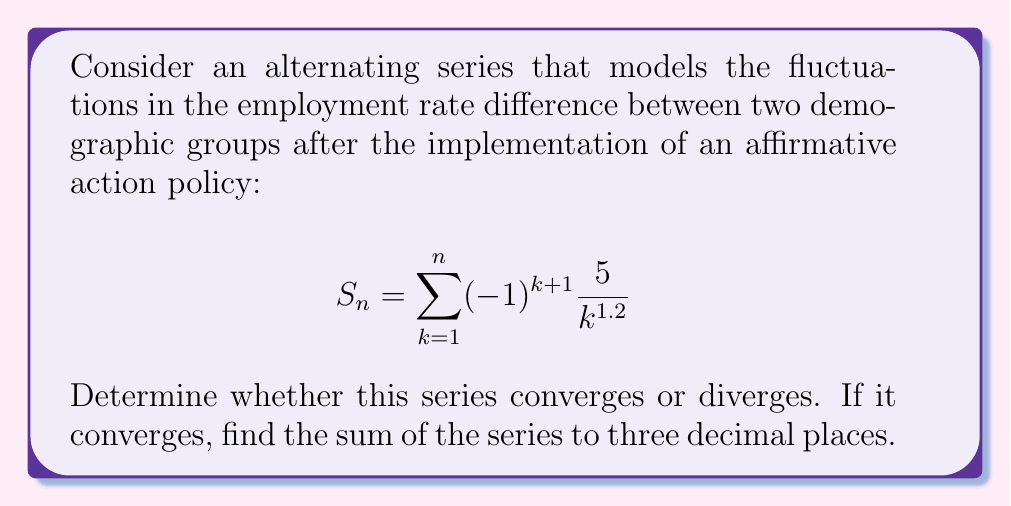Can you solve this math problem? To determine the convergence and sum of this alternating series, we'll use the Alternating Series Test and the Alternating Series Estimation Theorem.

Step 1: Check if the series meets the conditions for the Alternating Series Test.
a) The series alternates in sign: $(-1)^{k+1}$ ensures this.
b) $a_k = \frac{5}{k^{1.2}}$ is positive for all $k \geq 1$.
c) $a_k$ is decreasing: 
   $\frac{d}{dk}(\frac{5}{k^{1.2}}) = -6k^{-2.2} < 0$ for all $k > 0$.
d) $\lim_{k \to \infty} a_k = \lim_{k \to \infty} \frac{5}{k^{1.2}} = 0$

All conditions are met, so the series converges.

Step 2: Estimate the sum using the Alternating Series Estimation Theorem.
The error in stopping at the nth term is less than or equal to the absolute value of the (n+1)th term.

Let's calculate the partial sums until the error is less than 0.0005:

$S_1 = 5$
$S_2 = 5 - \frac{5}{2^{1.2}} \approx 2.7639$
$S_3 = 5 - \frac{5}{2^{1.2}} + \frac{5}{3^{1.2}} \approx 3.5972$
$S_4 \approx 3.2555$
$S_5 \approx 3.3910$

The error after the 5th term is:
$|\frac{5}{6^{1.2}}| \approx 0.4741 > 0.0005$

Continuing this process, we find that after the 23rd term, the error is less than 0.0005:
$|\frac{5}{24^{1.2}}| \approx 0.0004998 < 0.0005$

$S_{23} \approx 3.32185$

Therefore, the sum of the series to three decimal places is 3.322.
Answer: The series converges, and its sum is approximately 3.322. 